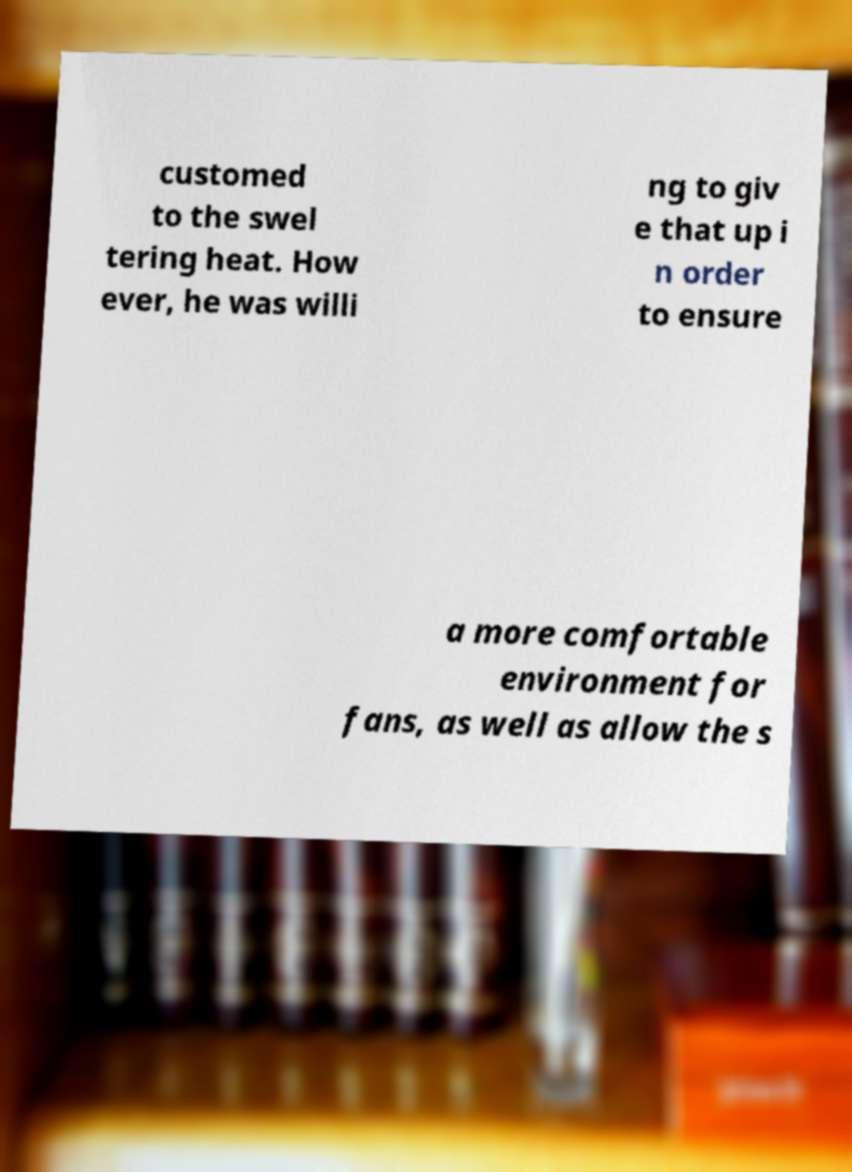I need the written content from this picture converted into text. Can you do that? customed to the swel tering heat. How ever, he was willi ng to giv e that up i n order to ensure a more comfortable environment for fans, as well as allow the s 